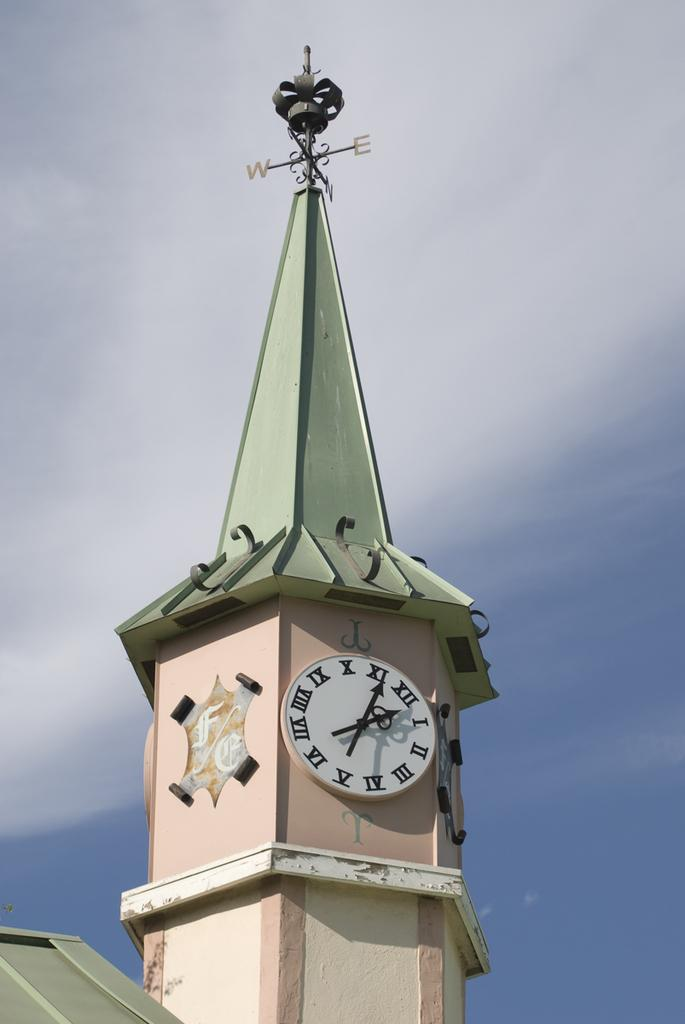What type of structure is the main subject of the image? There is a clock tower in the image. What can be used to determine directions in the image? There is a direction pole in the image. What is located at the bottom of the image? A roof and plants are visible at the bottom of the image. What is visible in the background of the image? The sky is visible in the background of the image. What can be observed in the sky? Clouds are present in the sky. What type of bomb is being detonated in the image? There is no bomb present in the image; it features a clock tower, direction pole, roof, plants, and a sky with clouds. What activity is taking place in the image? The image does not depict any specific activity; it shows a clock tower, direction pole, roof, plants, and a sky with clouds. 